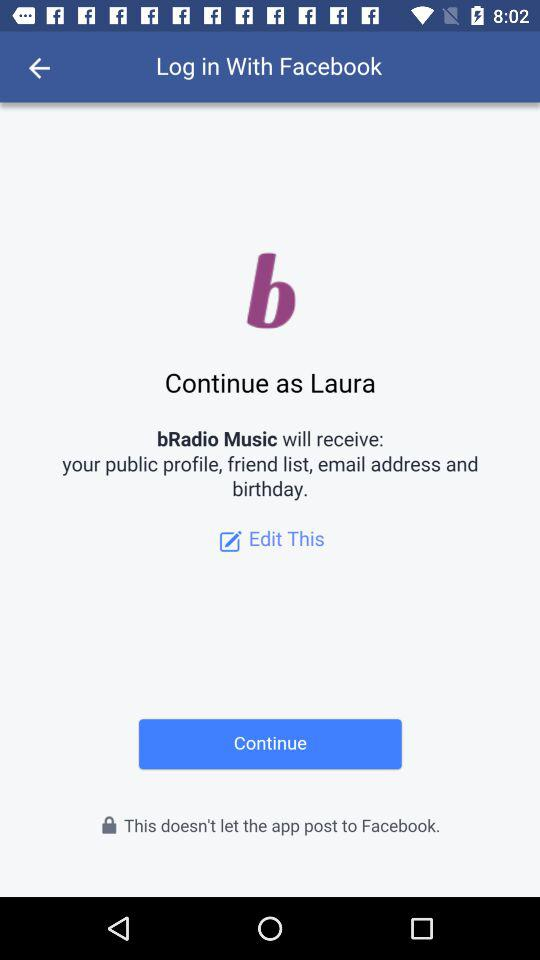Who is the application powered by?
When the provided information is insufficient, respond with <no answer>. <no answer> 